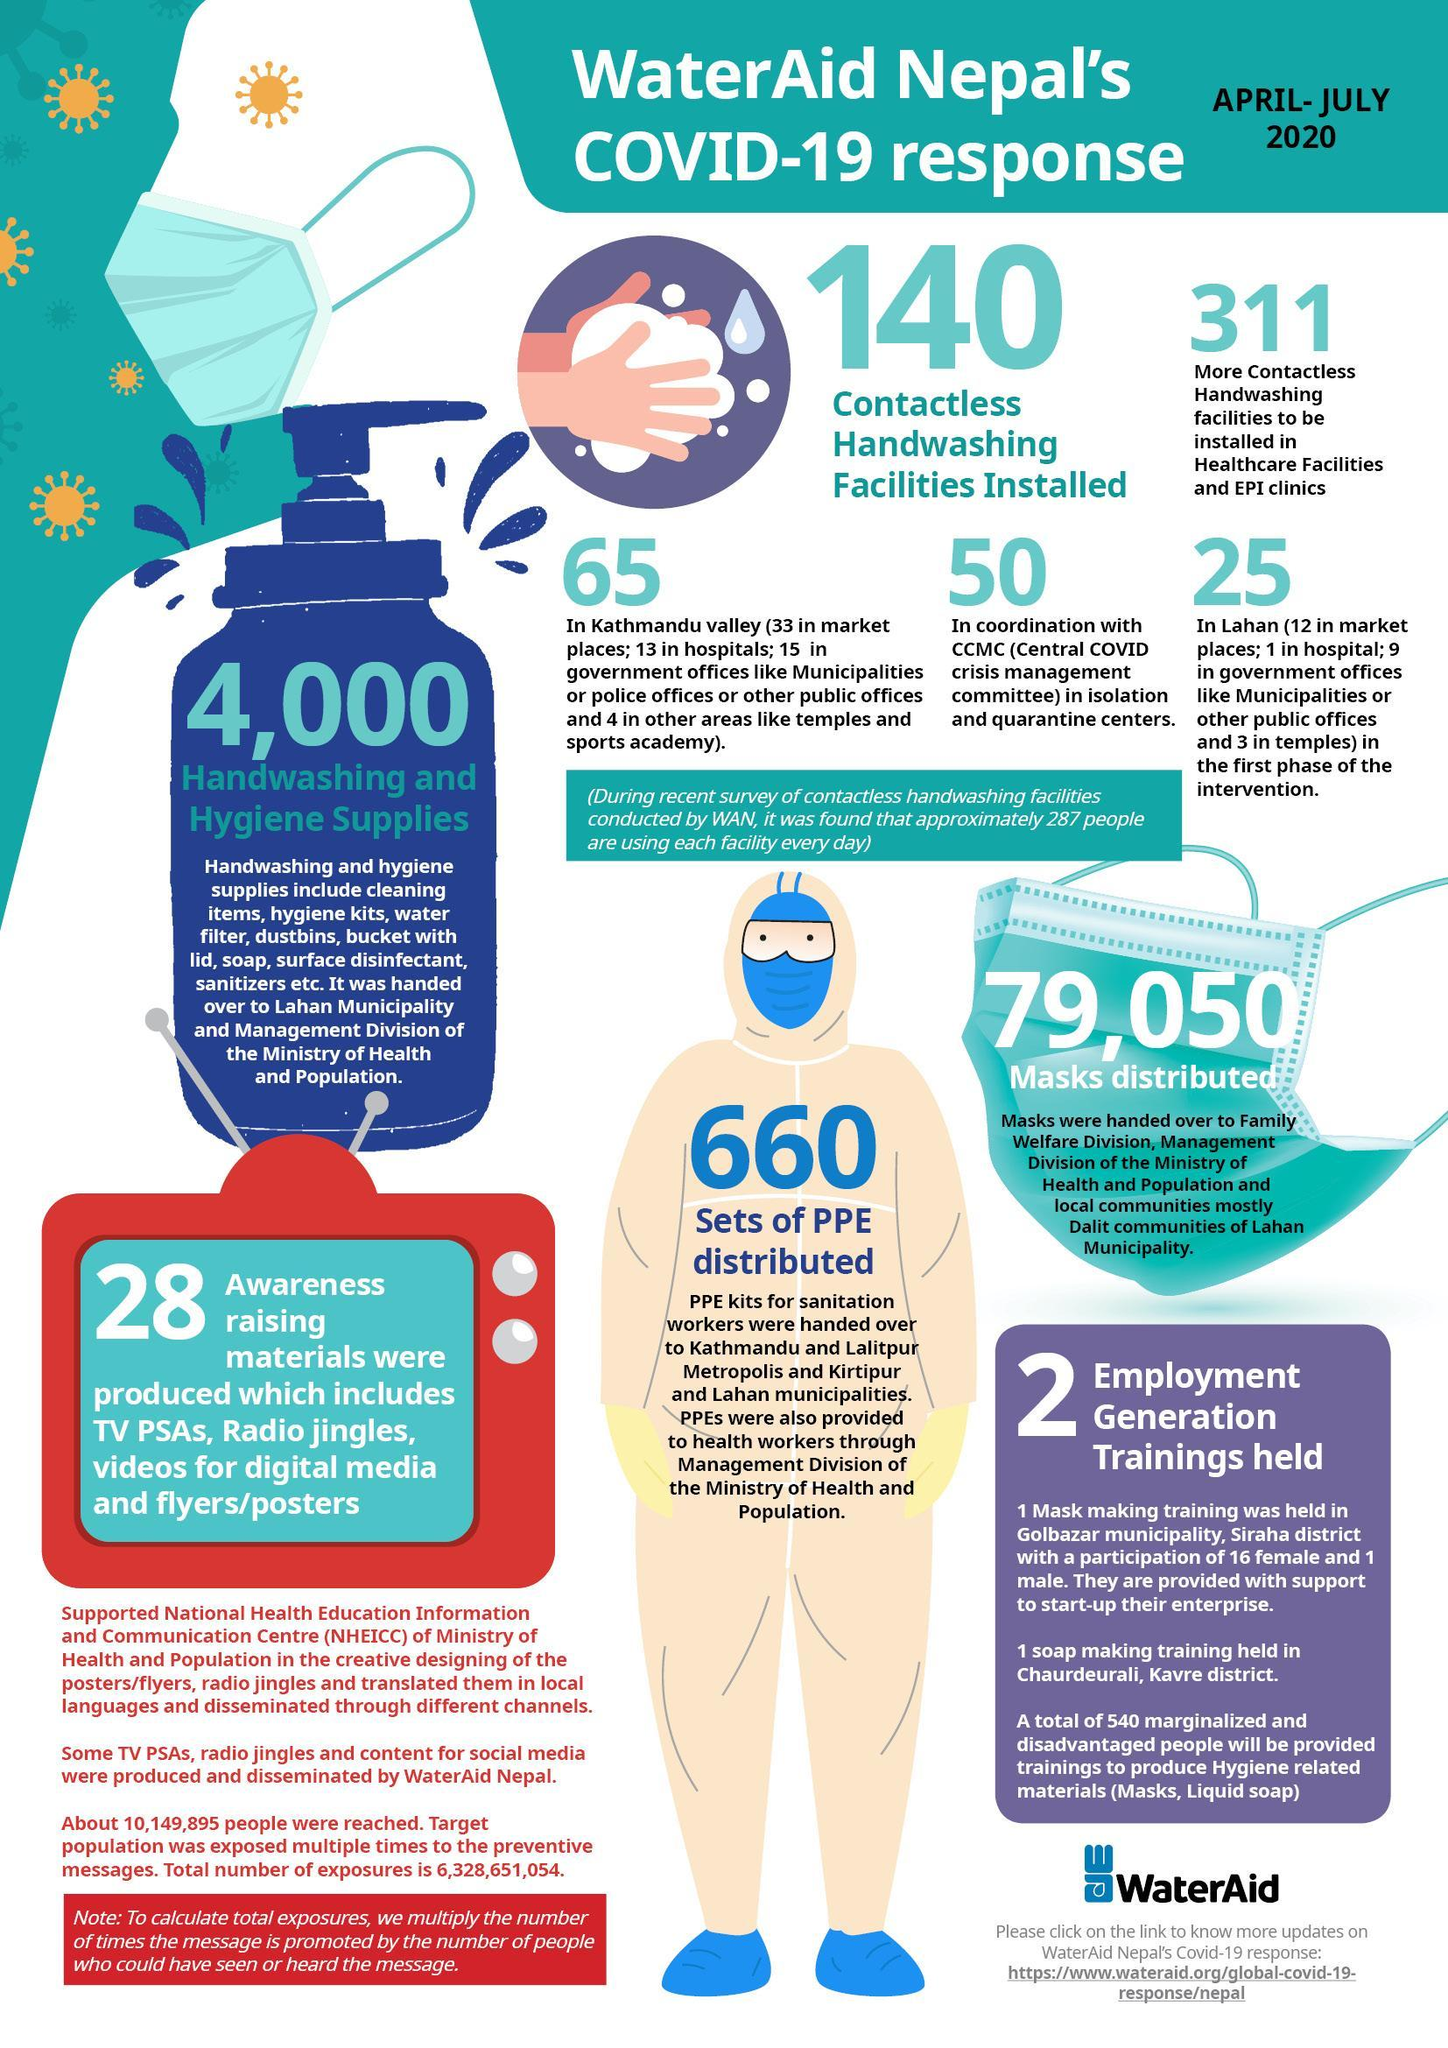What is the number of handwashing and hygiene supplies?
Answer the question with a short phrase. 4,000 How many contactless handwashing facilities installed? 140 How many masks distributed? 79,050 How many sets of PPE distributed? 660 